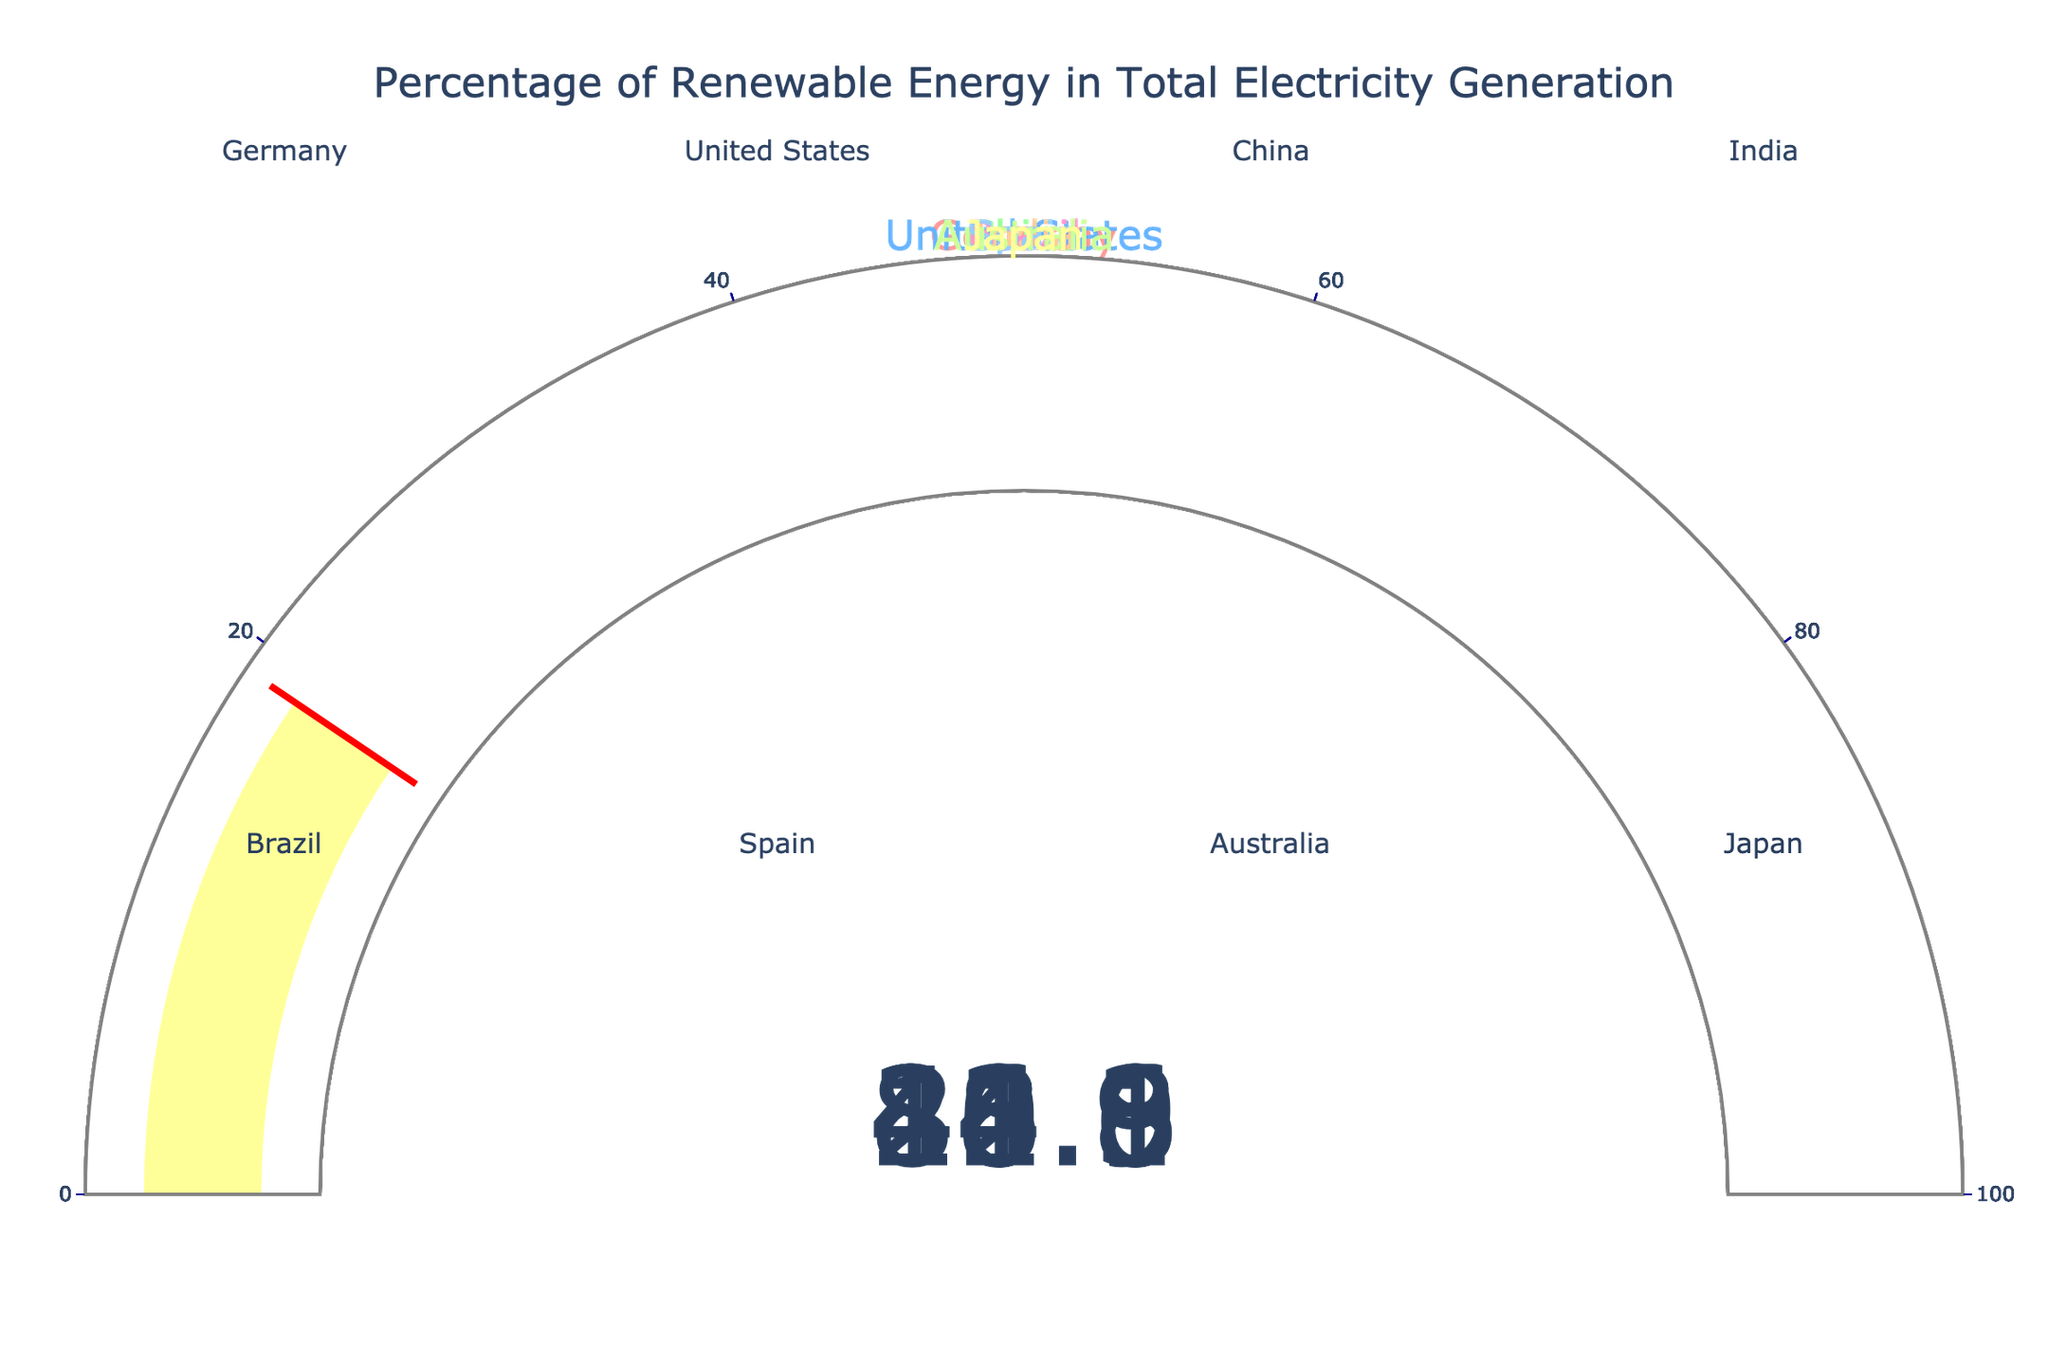What is the renewable energy percentage for Germany? The figure displays a gauge with the label "Germany" and a value of 46.1% in the center of the gauge.
Answer: 46.1% Which country has the highest renewable energy percentage? By comparing all the gauges, the gauge for Brazil shows a value of 84.1%, which is the highest among all countries displayed.
Answer: Brazil What is the average renewable energy percentage of the countries shown? Add the percentages of all countries and divide by the number of countries. (46.1 + 20.1 + 28.8 + 21.6 + 84.1 + 42.8 + 24.3 + 18.9) / 8 = 286.7 / 8 = 35.8375
Answer: 35.8% Which country has the lowest renewable energy percentage? Upon examining all gauges, Japan's gauge shows the lowest value at 18.9%.
Answer: Japan How much higher is Brazil's renewable energy percentage compared to the United States? Subtract the renewable energy percentage of the United States from Brazil's percentage: 84.1 - 20.1 = 64.0
Answer: 64.0 Which countries have a renewable energy percentage greater than 40%? By scanning all gauges, Germany (46.1%), Brazil (84.1%), and Spain (42.8%) have renewable energy percentages greater than 40%.
Answer: Germany, Brazil, Spain How many countries have a renewable energy percentage between 20% and 30%? Gauges for United States (20.1%), China (28.8%), and India (21.6%) fall within the range of 20% to 30%. Thus, three countries meet this criterion.
Answer: 3 Rank the countries from highest to lowest in terms of renewable energy percentage. By analyzing the values on the gauges: 1. Brazil (84.1%), 2. Germany (46.1%), 3. Spain (42.8%), 4. China (28.8%), 5. Australia (24.3%), 6. India (21.6%), 7. United States (20.1%), 8. Japan (18.9%).
Answer: Brazil, Germany, Spain, China, Australia, India, United States, Japan Is Germany's renewable energy percentage more than double that of Japan? Check if double of Japan's percentage (18.9% * 2 = 37.8%) is less than Germany's percentage (46.1%). Since 46.1% > 37.8%, Germany's renewable energy percentage is more than double.
Answer: Yes 